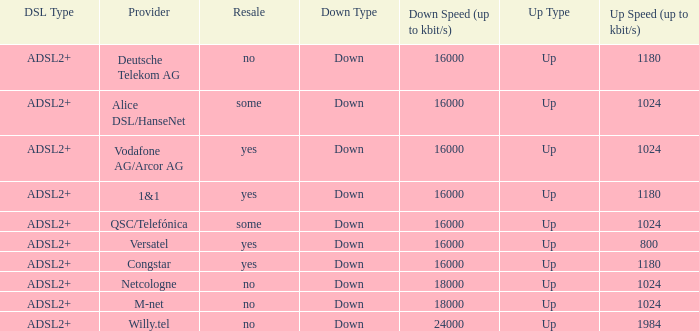What are all the dsl type offered by the M-Net telecom company? ADSL2+. 